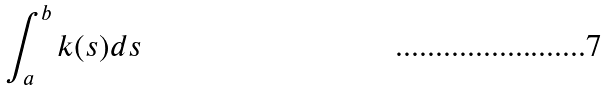<formula> <loc_0><loc_0><loc_500><loc_500>\int _ { a } ^ { b } k ( s ) d s</formula> 